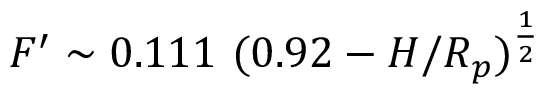Convert formula to latex. <formula><loc_0><loc_0><loc_500><loc_500>F ^ { \prime } \sim 0 . 1 1 1 ( 0 . 9 2 - H / R _ { p } ) ^ { \frac { 1 } { 2 } }</formula> 